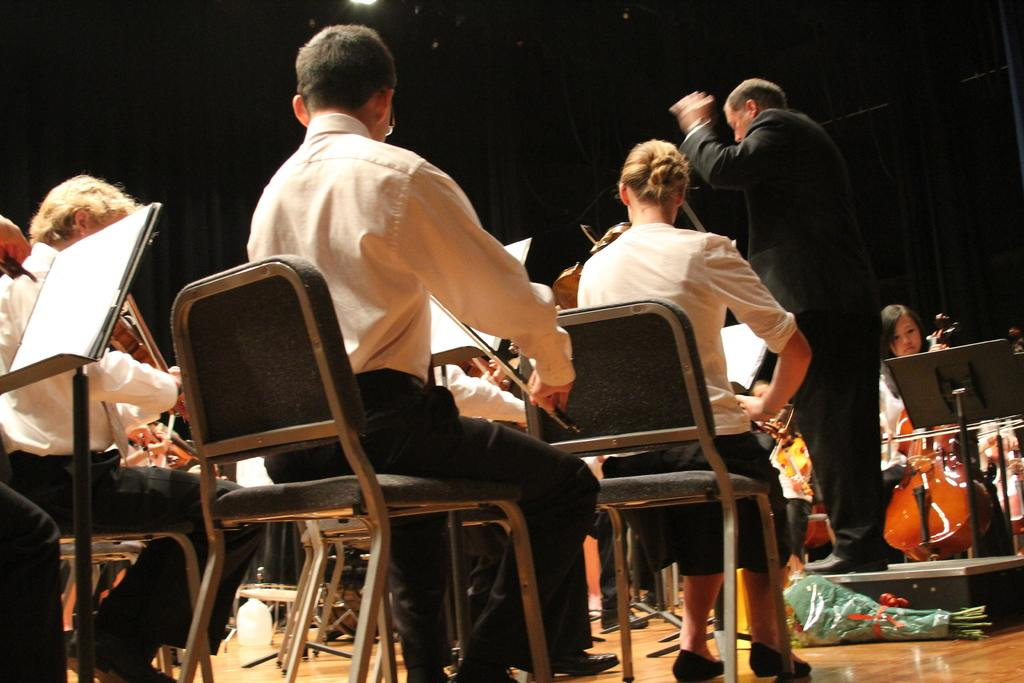What are the people in the room doing? The people in the room are sitting on chairs and playing violins. Is there anyone else in the room besides the people playing violins? Yes, there is a person standing in the middle of the room. What is the standing person doing? The standing person is giving instructions to the seated people. Where is the vase located in the room? There is no vase present in the image. How is the sponge being used for distribution in the room? There is no sponge present in the image, and therefore it cannot be used for distribution. 